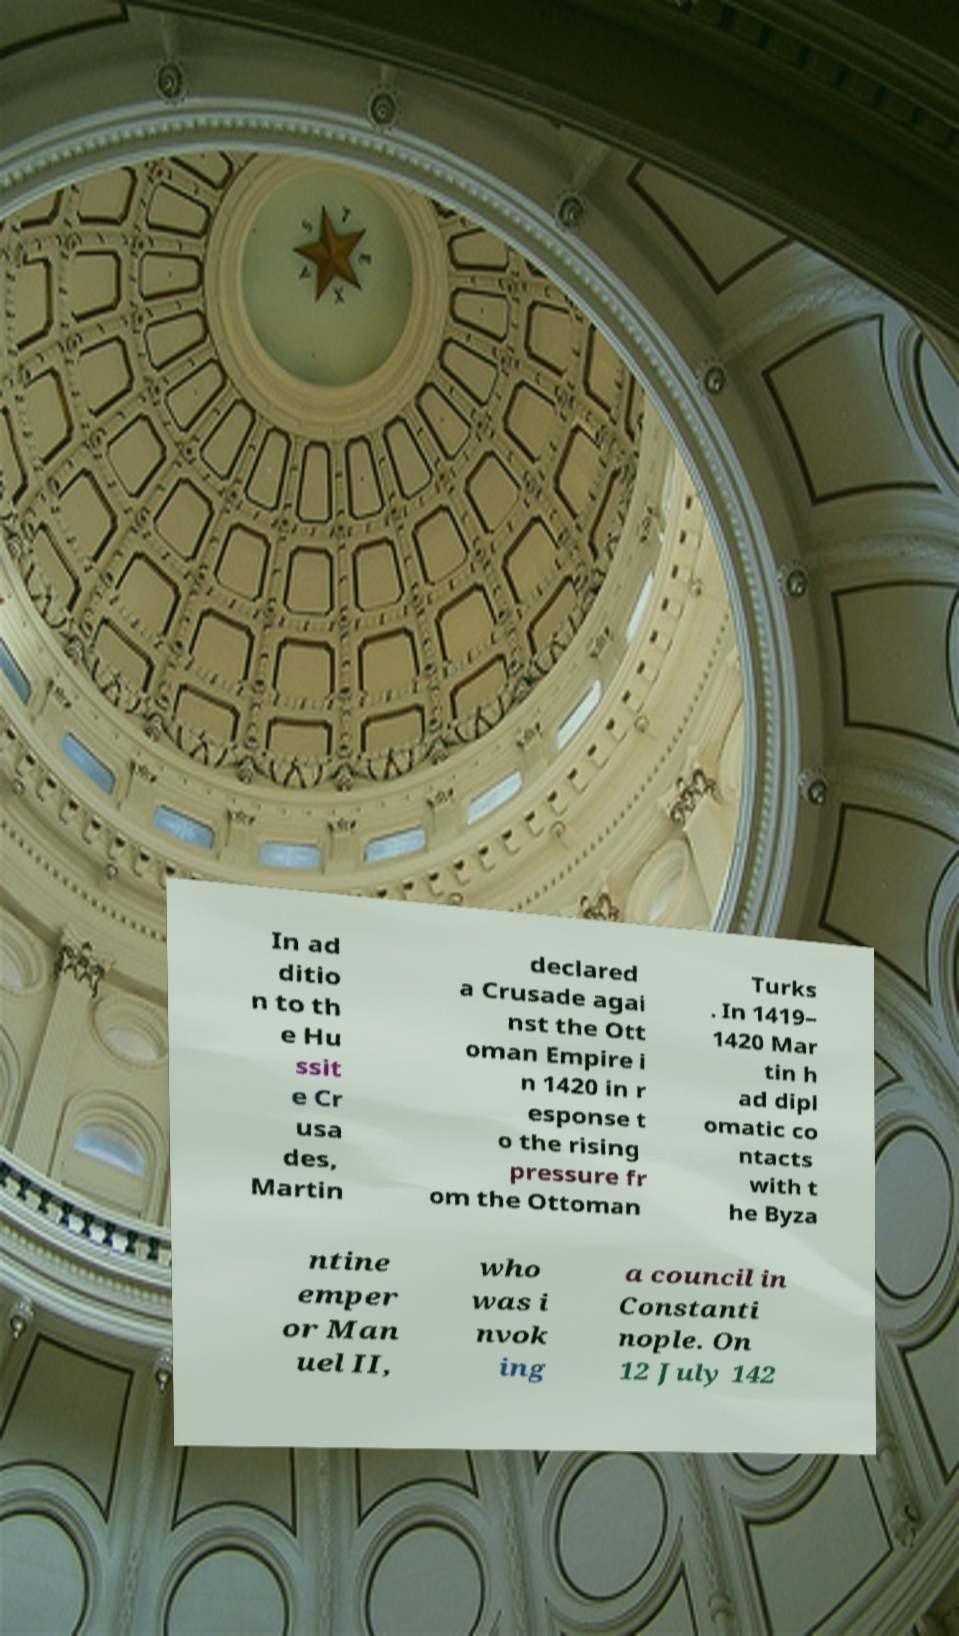For documentation purposes, I need the text within this image transcribed. Could you provide that? In ad ditio n to th e Hu ssit e Cr usa des, Martin declared a Crusade agai nst the Ott oman Empire i n 1420 in r esponse t o the rising pressure fr om the Ottoman Turks . In 1419– 1420 Mar tin h ad dipl omatic co ntacts with t he Byza ntine emper or Man uel II, who was i nvok ing a council in Constanti nople. On 12 July 142 